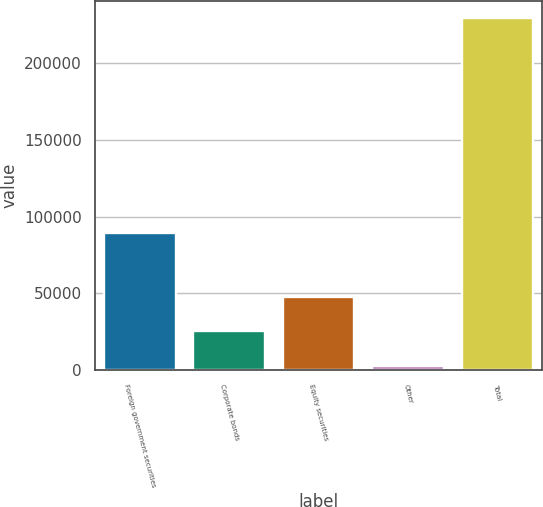<chart> <loc_0><loc_0><loc_500><loc_500><bar_chart><fcel>Foreign government securities<fcel>Corporate bonds<fcel>Equity securities<fcel>Other<fcel>Total<nl><fcel>89681<fcel>25296.2<fcel>47977.4<fcel>2615<fcel>229427<nl></chart> 